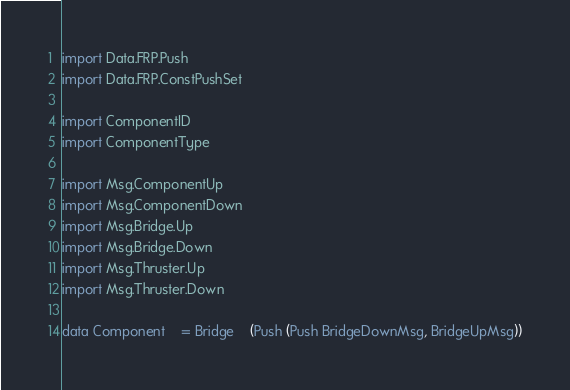Convert code to text. <code><loc_0><loc_0><loc_500><loc_500><_Haskell_>import Data.FRP.Push
import Data.FRP.ConstPushSet

import ComponentID
import ComponentType

import Msg.ComponentUp
import Msg.ComponentDown
import Msg.Bridge.Up
import Msg.Bridge.Down
import Msg.Thruster.Up
import Msg.Thruster.Down

data Component	= Bridge	(Push (Push BridgeDownMsg, BridgeUpMsg))</code> 